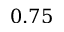Convert formula to latex. <formula><loc_0><loc_0><loc_500><loc_500>0 . 7 5</formula> 